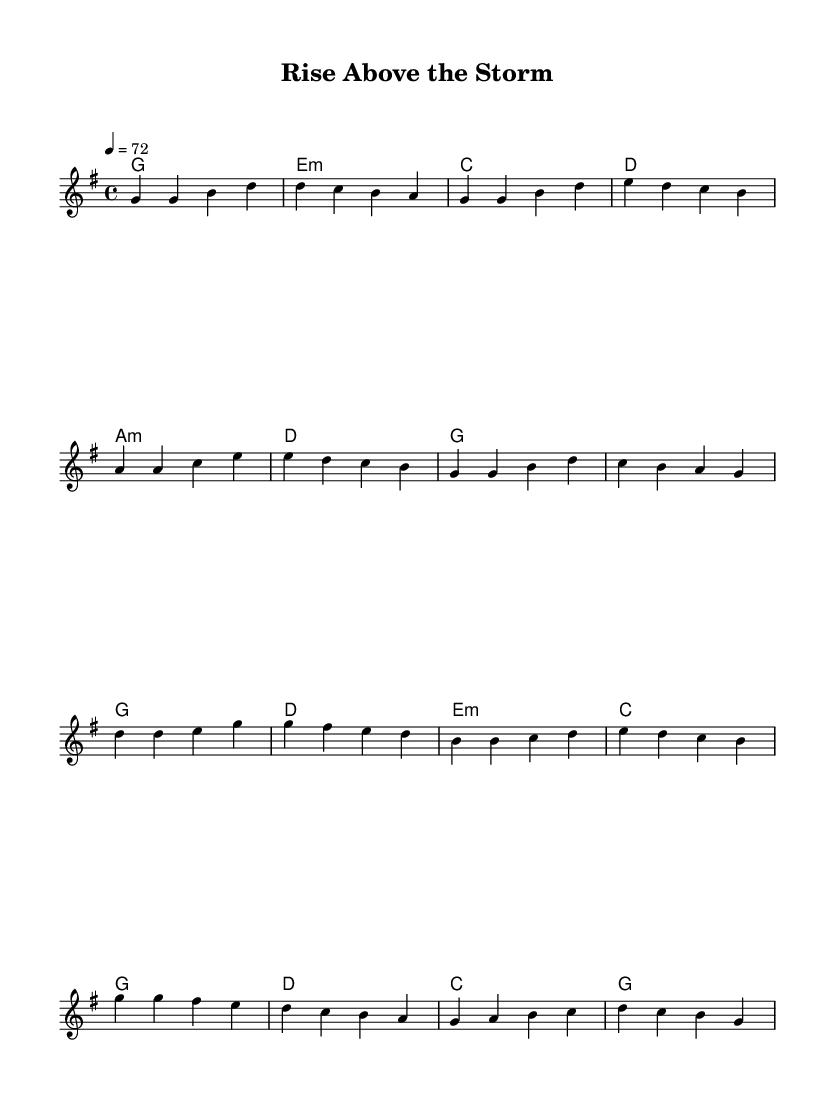What is the key signature of this music? The key signature is identified by looking at the beginning of the staff where sharps or flats are indicated. In this case, there are no sharps or flats shown, and it is indicated that the piece is in G major.
Answer: G major What is the time signature of the piece? The time signature can be found directly on the staff, and it is written as 4/4, which indicates there are four beats in a measure and the quarter note gets one beat.
Answer: 4/4 What is the tempo marking indicated in the sheet music? The tempo marking is present at the beginning of the score, indicating how fast the music should be played. Here, it is specified as quarter note equals 72 beats per minute.
Answer: 72 How many measures are there in the verse section? To find the number of measures, we can count the distinct groups of notes or chords after each bar line in the verse section. There are eight measures in the verse part.
Answer: Eight Identify the chord progression used in the chorus. The chords for the chorus can be seen in the harmonies section, which are played along with the melodic line. By analyzing the chord names, the progression is identified as G, D, E minor, C, G, D, C, G.
Answer: G, D, E minor, C, G, D, C, G What is the highest note in the melody? To identify the highest note, we review the melody notes, looking for the one with the highest pitch. The highest note present here is D, which appears in the chorus.
Answer: D Is this piece more likely to be a ballad or an uptempo song based on the sheet music? Analyzing both the tempo marking and structure, this piece is slower and designed to be expressive, fitting the characteristics of a ballad rather than an uptempo song.
Answer: Ballad 